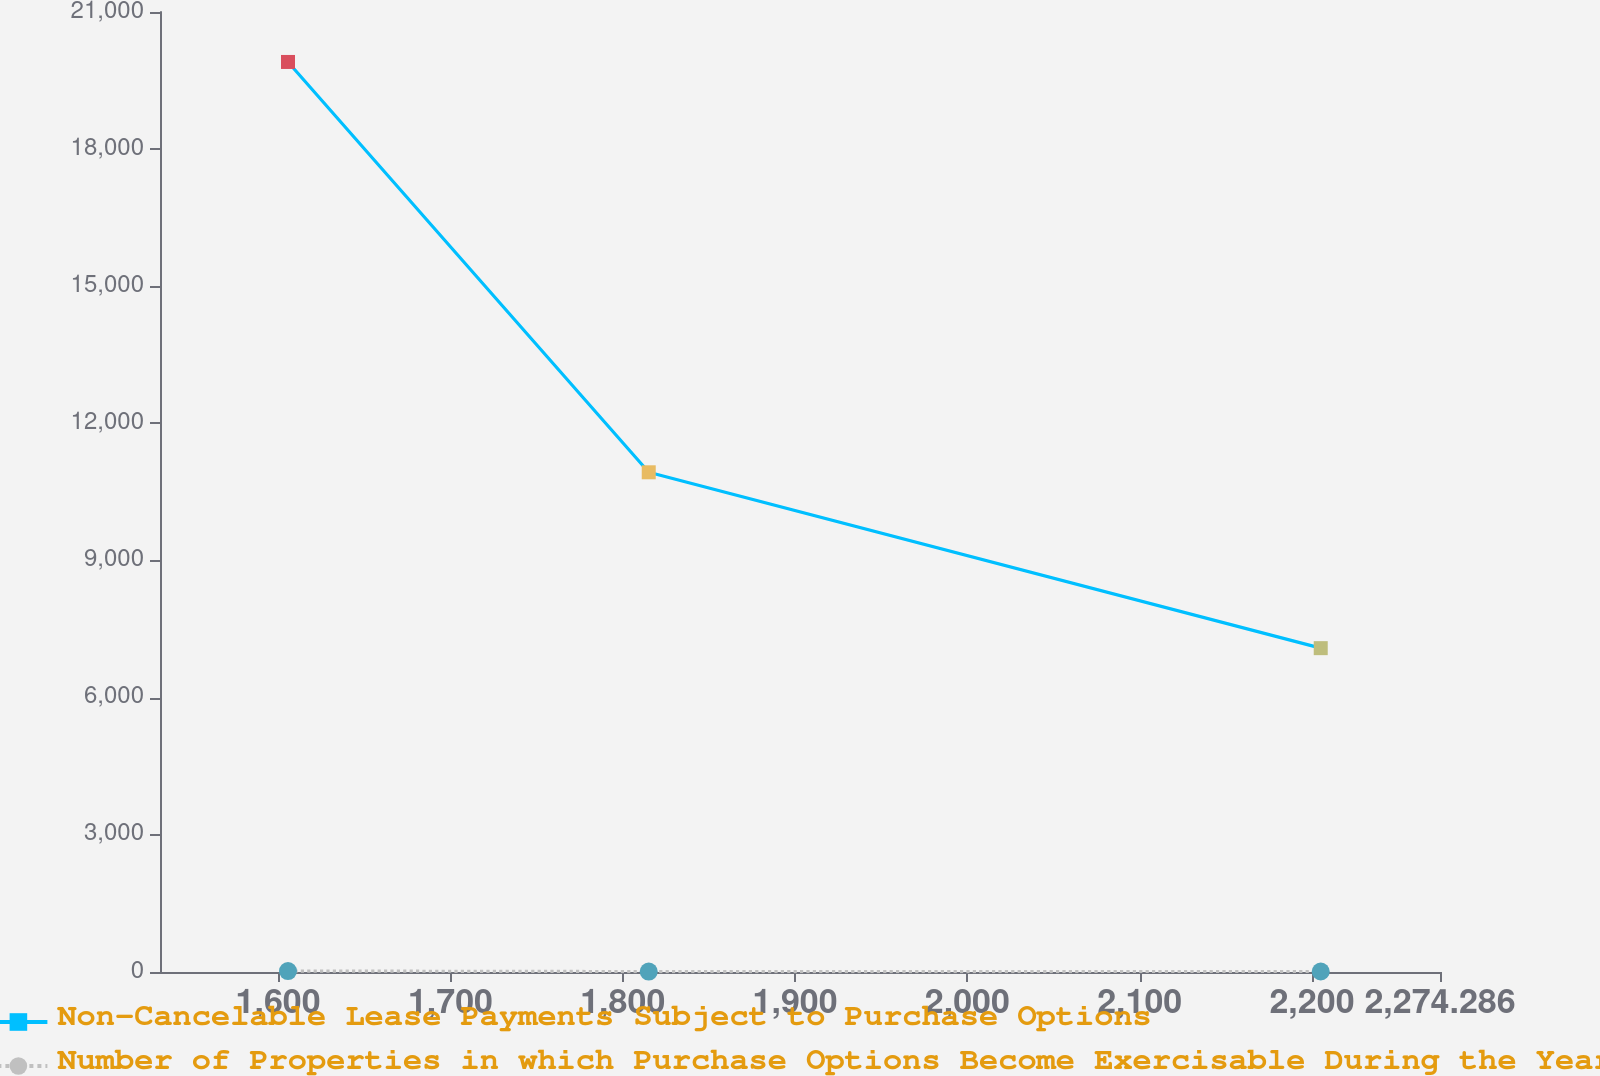Convert chart. <chart><loc_0><loc_0><loc_500><loc_500><line_chart><ecel><fcel>Non-Cancelable Lease Payments Subject to Purchase Options<fcel>Number of Properties in which Purchase Options Become Exercisable During the Year<nl><fcel>1605.73<fcel>19907.2<fcel>21.38<nl><fcel>1815.08<fcel>10930.9<fcel>9.36<nl><fcel>2205.07<fcel>7083.95<fcel>10.93<nl><fcel>2276.82<fcel>8366.28<fcel>5.7<nl><fcel>2348.57<fcel>9648.61<fcel>7.79<nl></chart> 